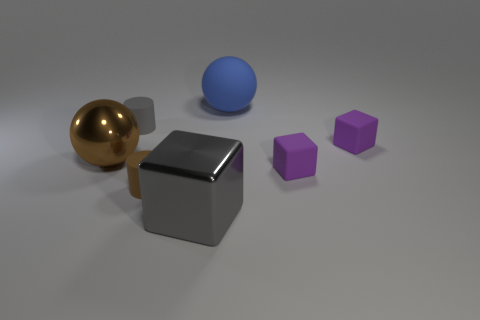Subtract all brown balls. How many balls are left? 1 Subtract all metallic blocks. How many blocks are left? 2 Subtract 0 green spheres. How many objects are left? 7 Subtract all cylinders. How many objects are left? 5 Subtract 1 spheres. How many spheres are left? 1 Subtract all brown cubes. Subtract all blue cylinders. How many cubes are left? 3 Subtract all cyan balls. How many blue cylinders are left? 0 Subtract all big yellow cubes. Subtract all small brown things. How many objects are left? 6 Add 1 brown objects. How many brown objects are left? 3 Add 4 tiny matte balls. How many tiny matte balls exist? 4 